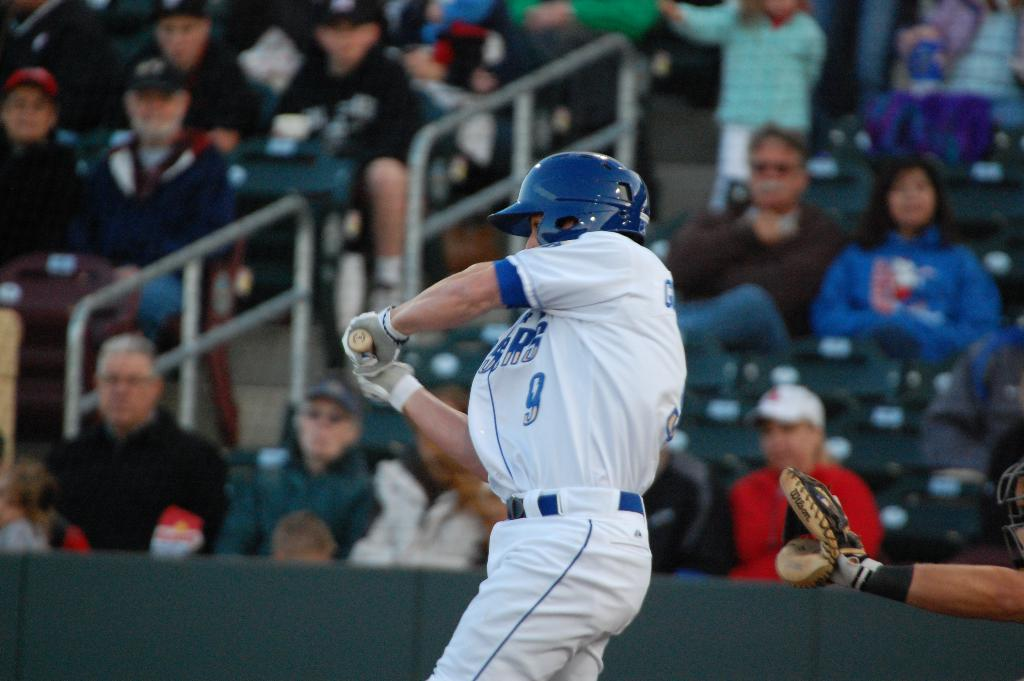<image>
Give a short and clear explanation of the subsequent image. Spectators watch as player number 9 swings the baseball bat in his blue and white uniform. 